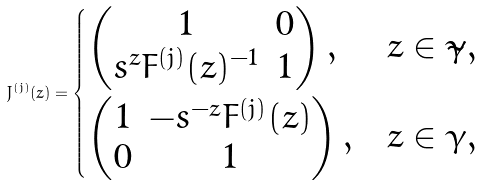Convert formula to latex. <formula><loc_0><loc_0><loc_500><loc_500>J ^ { ( j ) } ( z ) = \begin{dcases} \begin{pmatrix} 1 & 0 \\ s ^ { z } F ^ { ( j ) } ( z ) ^ { - 1 } & 1 \end{pmatrix} , & z \in \tilde { \gamma } , \\ \begin{pmatrix} 1 & - s ^ { - z } F ^ { ( j ) } ( z ) \\ 0 & 1 \end{pmatrix} , & z \in \gamma , \end{dcases}</formula> 